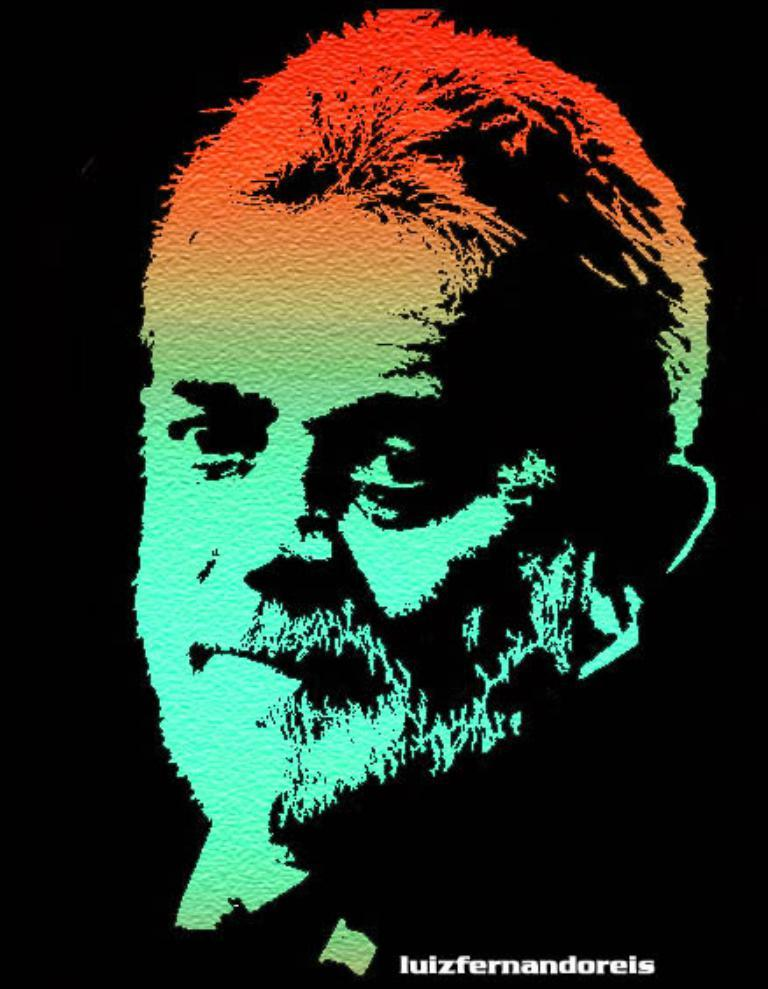What is the main subject of the image? There is a depiction of a person in the center of the image. Is there any text present in the image? Yes, there is text at the bottom of the image. What type of plantation is shown in the image? There is no plantation present in the image; it features a depiction of a person and text at the bottom. 